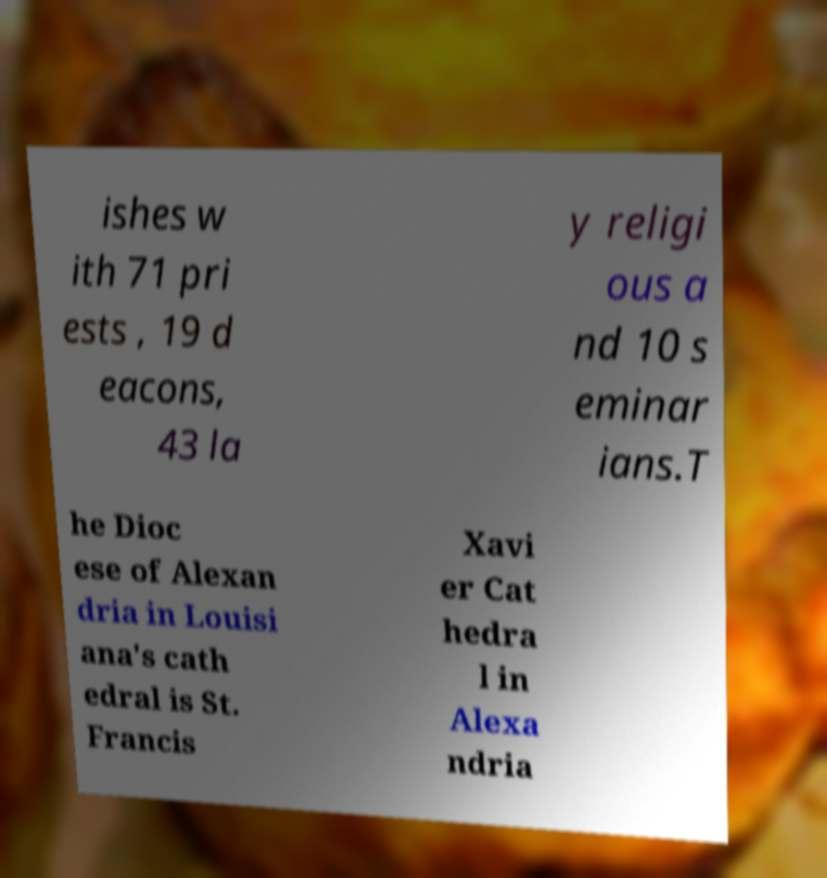Can you read and provide the text displayed in the image?This photo seems to have some interesting text. Can you extract and type it out for me? ishes w ith 71 pri ests , 19 d eacons, 43 la y religi ous a nd 10 s eminar ians.T he Dioc ese of Alexan dria in Louisi ana's cath edral is St. Francis Xavi er Cat hedra l in Alexa ndria 